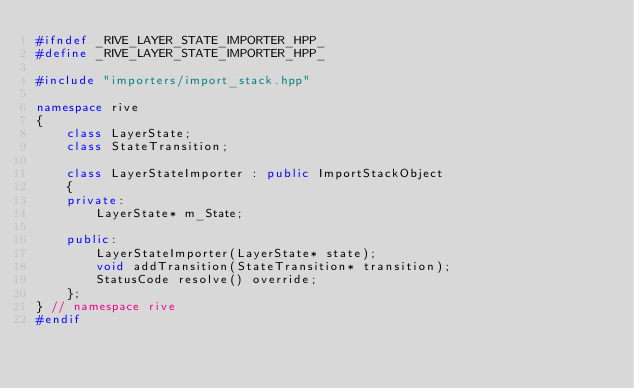<code> <loc_0><loc_0><loc_500><loc_500><_C++_>#ifndef _RIVE_LAYER_STATE_IMPORTER_HPP_
#define _RIVE_LAYER_STATE_IMPORTER_HPP_

#include "importers/import_stack.hpp"

namespace rive
{
	class LayerState;
	class StateTransition;

	class LayerStateImporter : public ImportStackObject
	{
	private:
		LayerState* m_State;

	public:
		LayerStateImporter(LayerState* state);
		void addTransition(StateTransition* transition);
		StatusCode resolve() override;
	};
} // namespace rive
#endif
</code> 